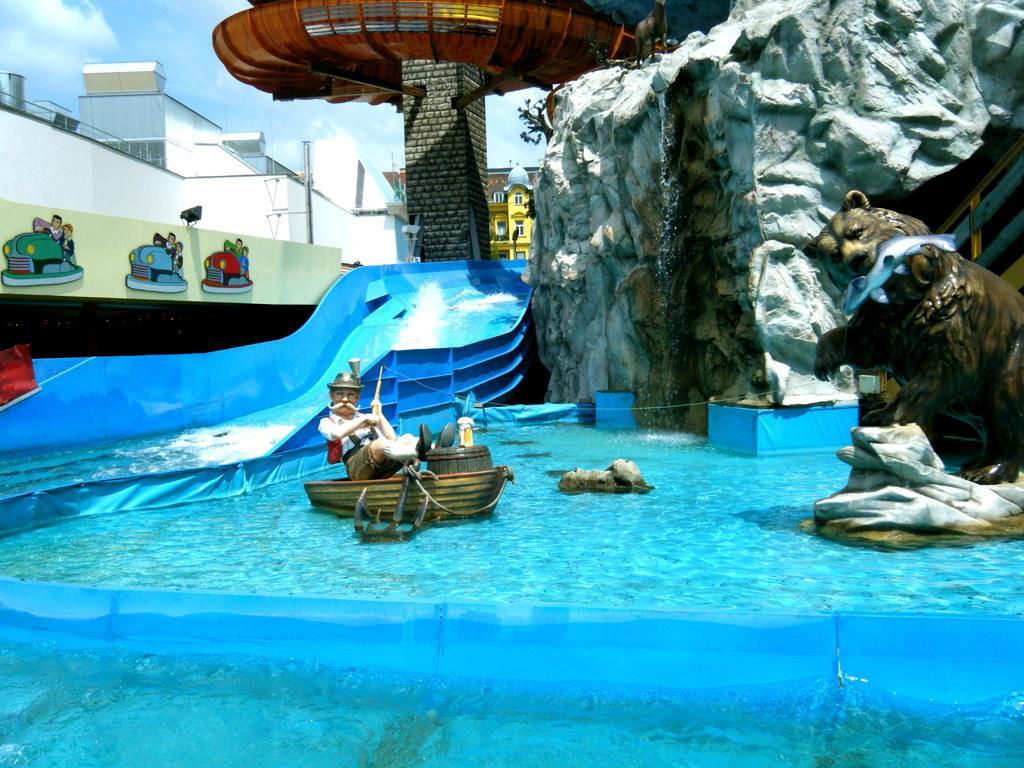Can you describe this image briefly? In this picture I can see the water and I see depiction of a boat, a man, a bear and a fish in the mouth of the bear. In the middle of this picture I see the slide, the wall on which there is art and I see the giant rock on the right side of this image. In the background I see the sky and number of buildings. 